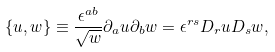Convert formula to latex. <formula><loc_0><loc_0><loc_500><loc_500>\{ u , w \} \equiv \frac { \epsilon ^ { a b } } { \sqrt { w } } \partial _ { a } u \partial _ { b } w = \epsilon ^ { r s } D _ { r } u D _ { s } w ,</formula> 